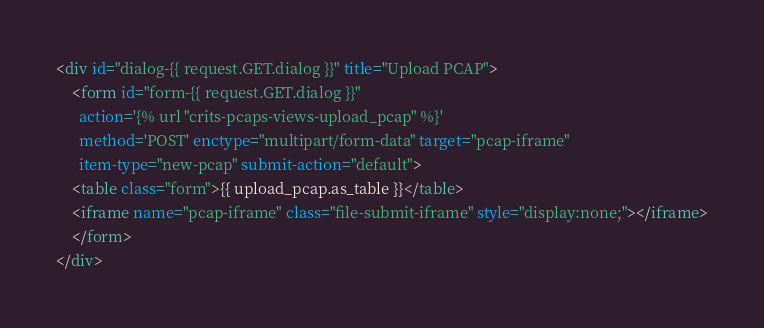<code> <loc_0><loc_0><loc_500><loc_500><_HTML_>

<div id="dialog-{{ request.GET.dialog }}" title="Upload PCAP">
    <form id="form-{{ request.GET.dialog }}" 
	  action='{% url "crits-pcaps-views-upload_pcap" %}' 
	  method='POST' enctype="multipart/form-data" target="pcap-iframe" 
	  item-type="new-pcap" submit-action="default">
    <table class="form">{{ upload_pcap.as_table }}</table>
    <iframe name="pcap-iframe" class="file-submit-iframe" style="display:none;"></iframe>
    </form>
</div>

</code> 